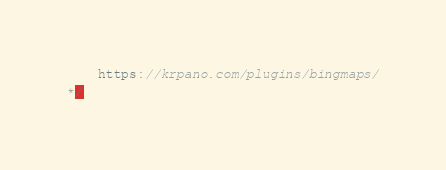<code> <loc_0><loc_0><loc_500><loc_500><_JavaScript_>	https://krpano.com/plugins/bingmaps/
*/</code> 